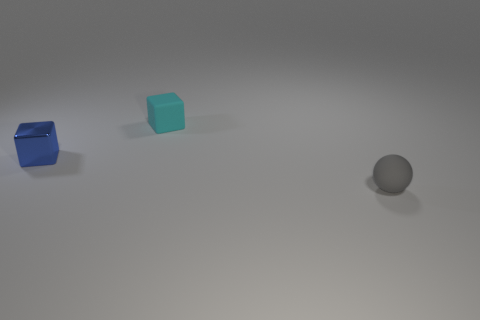What is the size of the other thing that is the same shape as the small blue metal thing?
Give a very brief answer. Small. How many other things are the same material as the tiny ball?
Offer a very short reply. 1. Are the ball and the tiny thing on the left side of the cyan matte cube made of the same material?
Offer a very short reply. No. Are there fewer cyan rubber blocks behind the tiny cyan block than tiny gray matte things that are to the left of the metal object?
Offer a very short reply. No. What is the color of the small matte object behind the tiny blue shiny cube?
Keep it short and to the point. Cyan. How many other things are the same color as the tiny shiny block?
Provide a succinct answer. 0. There is a rubber thing that is left of the sphere; is it the same size as the small rubber ball?
Make the answer very short. Yes. How many small rubber objects are in front of the gray ball?
Offer a very short reply. 0. Is there a brown block of the same size as the cyan matte cube?
Your response must be concise. No. Do the matte ball and the matte block have the same color?
Provide a succinct answer. No. 